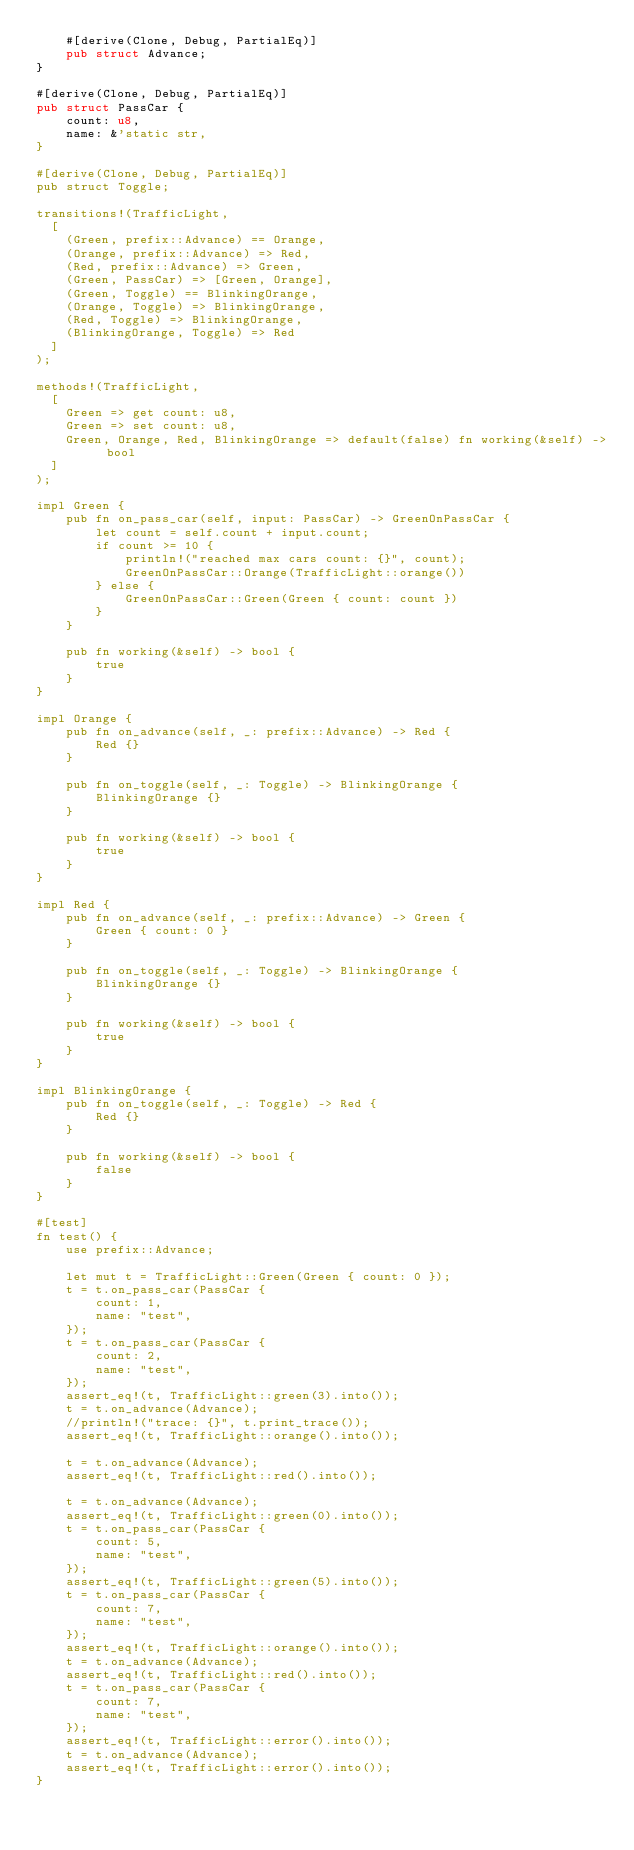Convert code to text. <code><loc_0><loc_0><loc_500><loc_500><_Rust_>    #[derive(Clone, Debug, PartialEq)]
    pub struct Advance;
}

#[derive(Clone, Debug, PartialEq)]
pub struct PassCar {
    count: u8,
    name: &'static str,
}

#[derive(Clone, Debug, PartialEq)]
pub struct Toggle;

transitions!(TrafficLight,
  [
    (Green, prefix::Advance) == Orange,
    (Orange, prefix::Advance) => Red,
    (Red, prefix::Advance) => Green,
    (Green, PassCar) => [Green, Orange],
    (Green, Toggle) == BlinkingOrange,
    (Orange, Toggle) => BlinkingOrange,
    (Red, Toggle) => BlinkingOrange,
    (BlinkingOrange, Toggle) => Red
  ]
);

methods!(TrafficLight,
  [
    Green => get count: u8,
    Green => set count: u8,
    Green, Orange, Red, BlinkingOrange => default(false) fn working(&self) -> bool
  ]
);

impl Green {
    pub fn on_pass_car(self, input: PassCar) -> GreenOnPassCar {
        let count = self.count + input.count;
        if count >= 10 {
            println!("reached max cars count: {}", count);
            GreenOnPassCar::Orange(TrafficLight::orange())
        } else {
            GreenOnPassCar::Green(Green { count: count })
        }
    }

    pub fn working(&self) -> bool {
        true
    }
}

impl Orange {
    pub fn on_advance(self, _: prefix::Advance) -> Red {
        Red {}
    }

    pub fn on_toggle(self, _: Toggle) -> BlinkingOrange {
        BlinkingOrange {}
    }

    pub fn working(&self) -> bool {
        true
    }
}

impl Red {
    pub fn on_advance(self, _: prefix::Advance) -> Green {
        Green { count: 0 }
    }

    pub fn on_toggle(self, _: Toggle) -> BlinkingOrange {
        BlinkingOrange {}
    }

    pub fn working(&self) -> bool {
        true
    }
}

impl BlinkingOrange {
    pub fn on_toggle(self, _: Toggle) -> Red {
        Red {}
    }

    pub fn working(&self) -> bool {
        false
    }
}

#[test]
fn test() {
    use prefix::Advance;

    let mut t = TrafficLight::Green(Green { count: 0 });
    t = t.on_pass_car(PassCar {
        count: 1,
        name: "test",
    });
    t = t.on_pass_car(PassCar {
        count: 2,
        name: "test",
    });
    assert_eq!(t, TrafficLight::green(3).into());
    t = t.on_advance(Advance);
    //println!("trace: {}", t.print_trace());
    assert_eq!(t, TrafficLight::orange().into());

    t = t.on_advance(Advance);
    assert_eq!(t, TrafficLight::red().into());

    t = t.on_advance(Advance);
    assert_eq!(t, TrafficLight::green(0).into());
    t = t.on_pass_car(PassCar {
        count: 5,
        name: "test",
    });
    assert_eq!(t, TrafficLight::green(5).into());
    t = t.on_pass_car(PassCar {
        count: 7,
        name: "test",
    });
    assert_eq!(t, TrafficLight::orange().into());
    t = t.on_advance(Advance);
    assert_eq!(t, TrafficLight::red().into());
    t = t.on_pass_car(PassCar {
        count: 7,
        name: "test",
    });
    assert_eq!(t, TrafficLight::error().into());
    t = t.on_advance(Advance);
    assert_eq!(t, TrafficLight::error().into());
}
</code> 